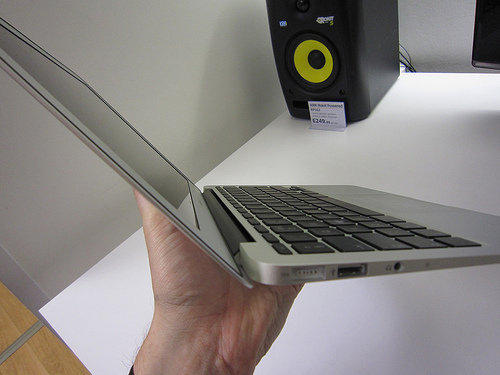<image>
Can you confirm if the speaker is in front of the laptop? Yes. The speaker is positioned in front of the laptop, appearing closer to the camera viewpoint. Is there a person in front of the laptop? No. The person is not in front of the laptop. The spatial positioning shows a different relationship between these objects. Where is the laptop in relation to the table? Is it above the table? Yes. The laptop is positioned above the table in the vertical space, higher up in the scene. 